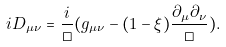<formula> <loc_0><loc_0><loc_500><loc_500>i D _ { \mu \nu } = \frac { i } { \Box } ( g _ { \mu \nu } - ( 1 - \xi ) \frac { \partial _ { \mu } \partial _ { \nu } } { \Box } ) .</formula> 